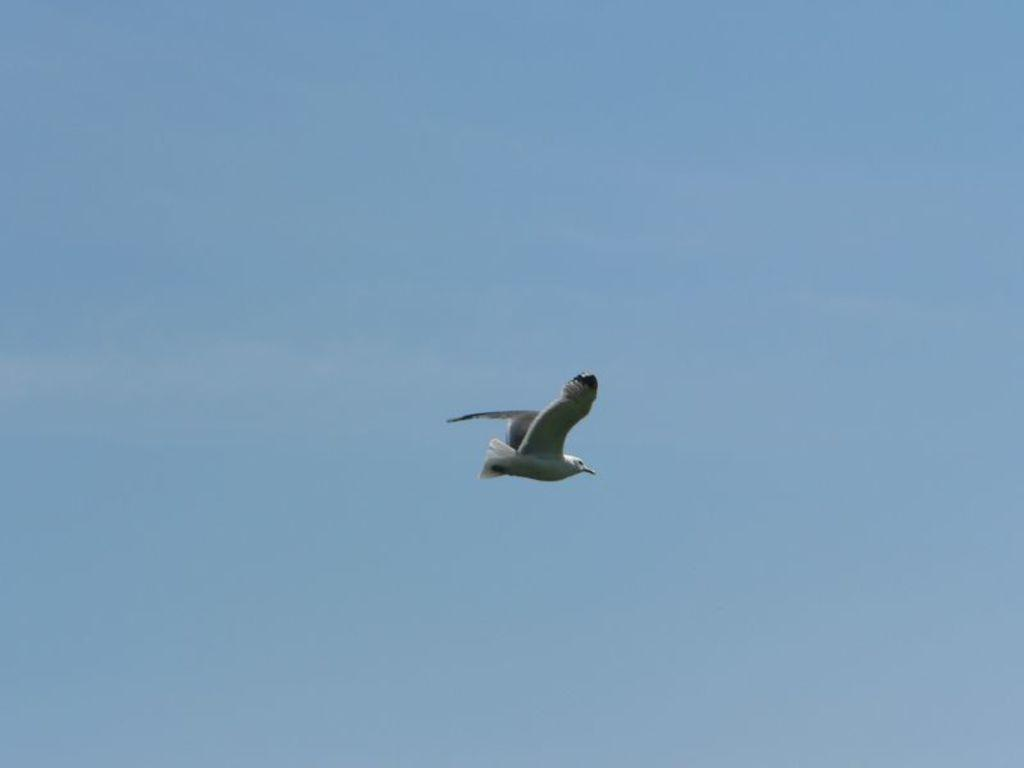What type of animal can be seen in the image? There is a bird in the image. What is the bird doing in the image? The bird is flying. What color is the bird in the image? The bird is white in color. What can be seen in the background of the image? There is a sky visible in the background of the image. What type of history can be seen in the image? There is no history present in the image; it features a white bird flying against a sky background. What type of cabbage is being used as a prop in the image? There is no cabbage present in the image. 